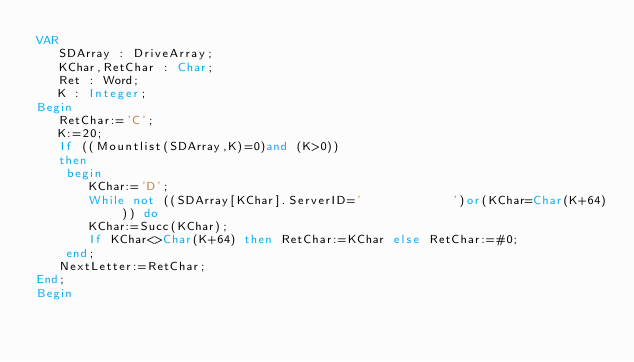<code> <loc_0><loc_0><loc_500><loc_500><_Pascal_>VAR
   SDArray : DriveArray;
   KChar,RetChar : Char;
   Ret : Word;
   K : Integer;
Begin
   RetChar:='C';
   K:=20;
   If ((Mountlist(SDArray,K)=0)and (K>0))
   then
    begin
       KChar:='D';
       While not ((SDArray[KChar].ServerID='            ')or(KChar=Char(K+64))) do
       KChar:=Succ(KChar);
       If KChar<>Char(K+64) then RetChar:=KChar else RetChar:=#0;
    end;
   NextLetter:=RetChar;
End;
Begin</code> 